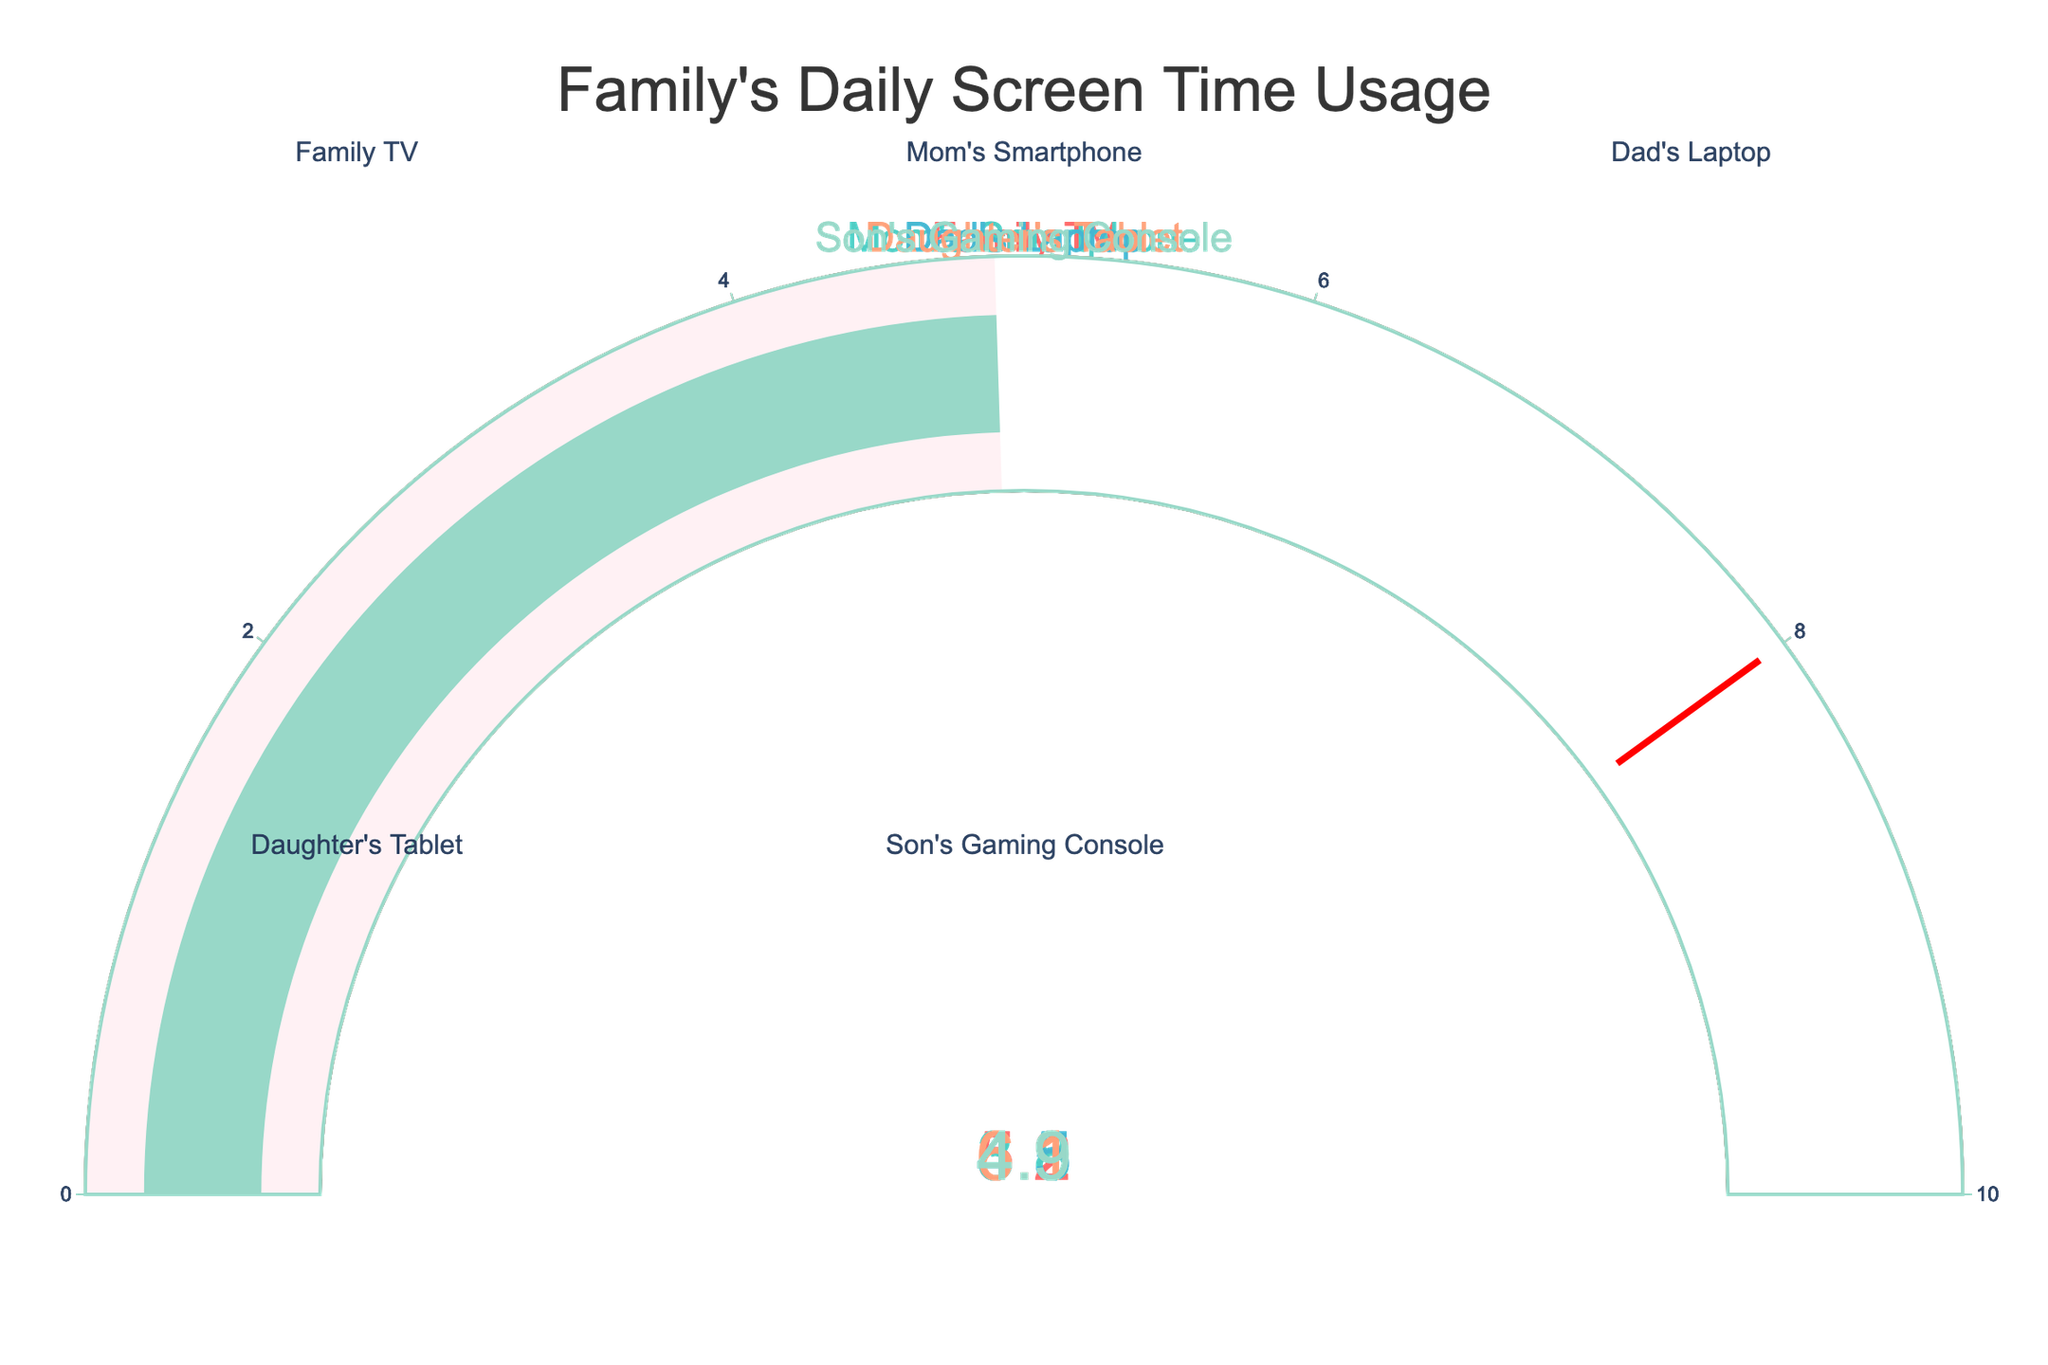What is the screen time for the Family TV? The gauge chart for the Family TV shows that the screen time is displayed on the gauge. The number shown is directly on the gauge.
Answer: 5.2 hours Which device has the highest daily screen time usage? Compare all the values shown on the gauge charts. The highest value among the devices is for the Daughter's Tablet.
Answer: Daughter's Tablet What is the difference in screen time between Mom's Smartphone and Dad's Laptop? The gauge chart for Mom's Smartphone shows 3.8 hours, and for Dad's Laptop shows 4.5 hours. Subtract the smaller value from the larger value: 4.5 - 3.8.
Answer: 0.7 hours Which device has the lowest daily screen time usage? Among all the gauge charts, identify the lowest value. The lowest value is found on Mom's Smartphone.
Answer: Mom's Smartphone How much more screen time does the Son's Gaming Console have compared to the Family TV? The gauge chart shows Son's Gaming Console screen time as 4.9 hours and Family TV as 5.2 hours. Subtract the Family TV's screen time from the Son's Gaming Console's screen time: 4.9 - 5.2.
Answer: -0.3 hours What is the average daily screen time for all devices? Sum all the screen time values: 5.2 (Family TV) + 3.8 (Mom's Smartphone) + 4.5 (Dad's Laptop) + 6.1 (Daughter's Tablet) + 4.9 (Son's Gaming Console) = 24.5. Then divide by the number of devices: 24.5 / 5.
Answer: 4.9 hours Is there any device that exceeds the threshold of 8 hours? Check each gauge chart to see if any value exceeds the threshold marked in red. None of the devices exceed the threshold of 8 hours.
Answer: No Which two devices have the closest amount of screen time? Compare the differences in screen time between each pair of devices. The smallest difference is between Son's Gaming Console (4.9 hours) and Dad's Laptop (4.5 hours): 4.9 - 4.5.
Answer: Son's Gaming Console and Dad's Laptop What is the total daily screen time for the family? Sum all the screen time values shown on the gauge charts: 5.2 (Family TV) + 3.8 (Mom's Smartphone) + 4.5 (Dad's Laptop) + 6.1 (Daughter's Tablet) + 4.9 (Son's Gaming Console).
Answer: 24.5 hours 